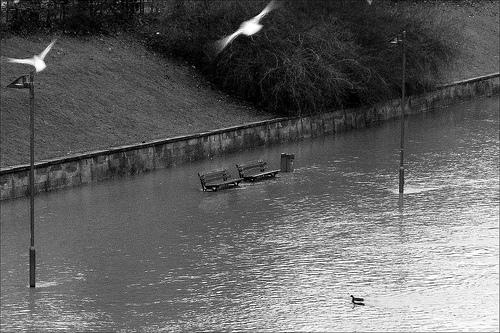Briefly explain the main features of the image and their context. A bird is flying in the sky, while below, park benches and light poles are partially submerged in floodwaters with a duck wading nearby. Provide a short and descriptive overview of the image. A white bird soars through the sky above a flooded park, featuring submerged benches, a wading duck, and partially flooded light poles. Express the main idea of the image in a short phrase. Bird flying above flooded park with benches and duck. Give a simple and concise description of the image. A bird flies over a flooded park with benches, a duck, and partially submerged light poles. Narrate what is happening in the photo using simple language. A white bird is flying high while park benches and light poles are in water, and a duck is swimming around. Provide a brief overview of the objects and their interactions in the photo. A white bird is flying in the sky, benches are sitting in floodwater below, and a duck wades around in the water as light poles sit partially submerged and a wall retains water flow.  Mention the primary focus of the image and its action. The image mainly shows a white bird soaring in the sky, and two park benches submerged in floodwater. Use one sentence to describe the main components of the image. The image displays a white bird in the sky and submerged park benches in floodwater, with a duck and light poles also in the water. State the key elements captured in the image and the scene. In the scene, a white bird flies above as park benches, a duck, and light poles are situated in floodwaters, with trees and bushes in the background. Summarize the contents of the photo in a concise manner. This is a black and white photo of a bird flying, benches submerged in water, and a duck wading during a flood. 